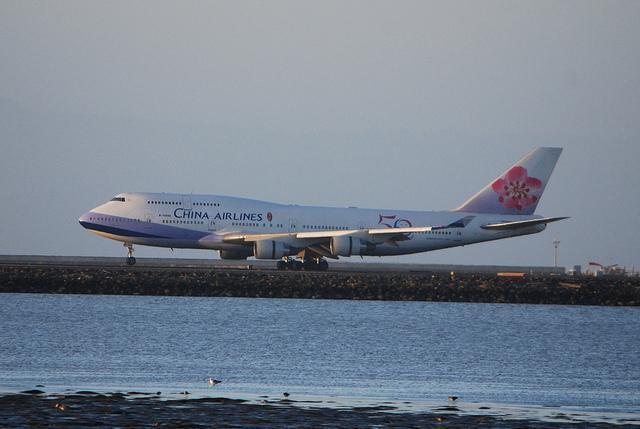How many planes are on the water?
Give a very brief answer. 0. How many black and white dogs are in the image?
Give a very brief answer. 0. 